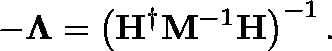Convert formula to latex. <formula><loc_0><loc_0><loc_500><loc_500>- \Lambda = \left ( H ^ { \dagger } M ^ { - 1 } H \right ) ^ { - 1 } .</formula> 